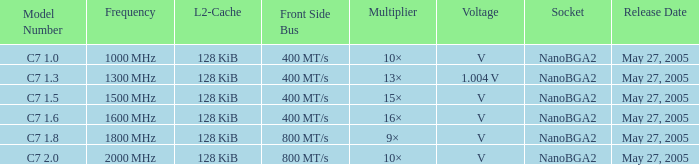What is the front side bus for model number c7 400 MT/s. 